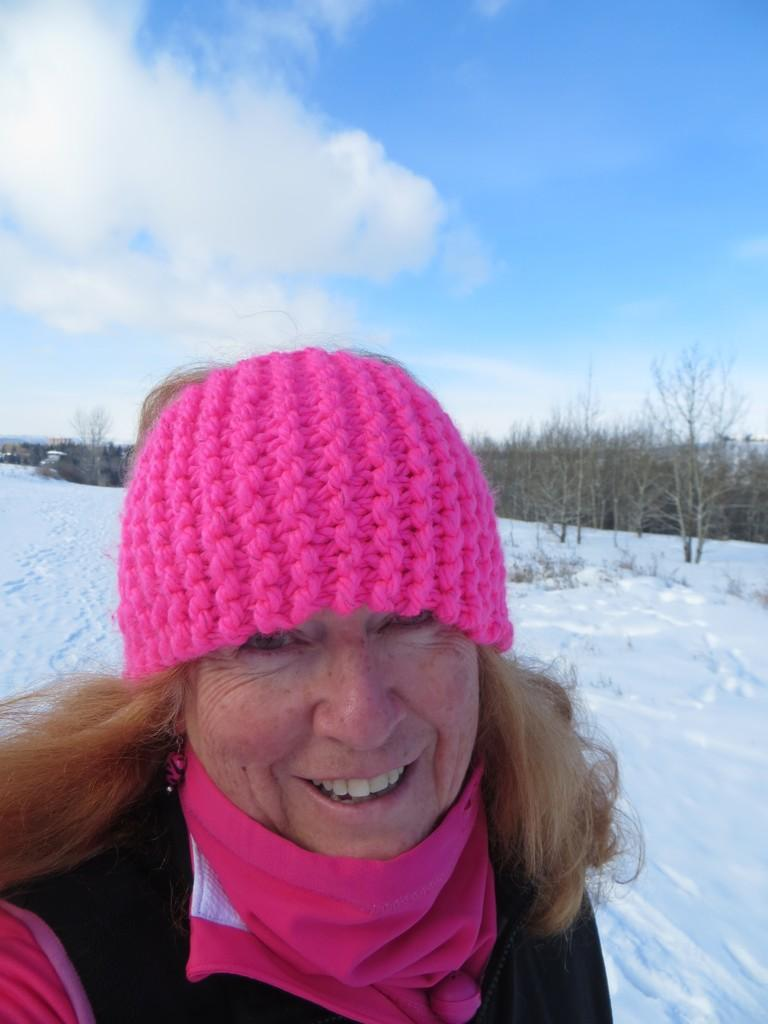Who is the main subject in the image? There is a lady in the middle of the image. What is the lady wearing on her head? The lady is wearing a pink cap. What is the setting of the image? There is snow in the background of the image, and trees are visible in the snow. What is visible at the top of the image? The sky is visible at the top of the image. What type of rifle is being used by the lady in the image? There is no rifle present in the image; it features a lady wearing a pink cap in a snowy setting. 